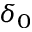Convert formula to latex. <formula><loc_0><loc_0><loc_500><loc_500>\delta _ { 0 }</formula> 